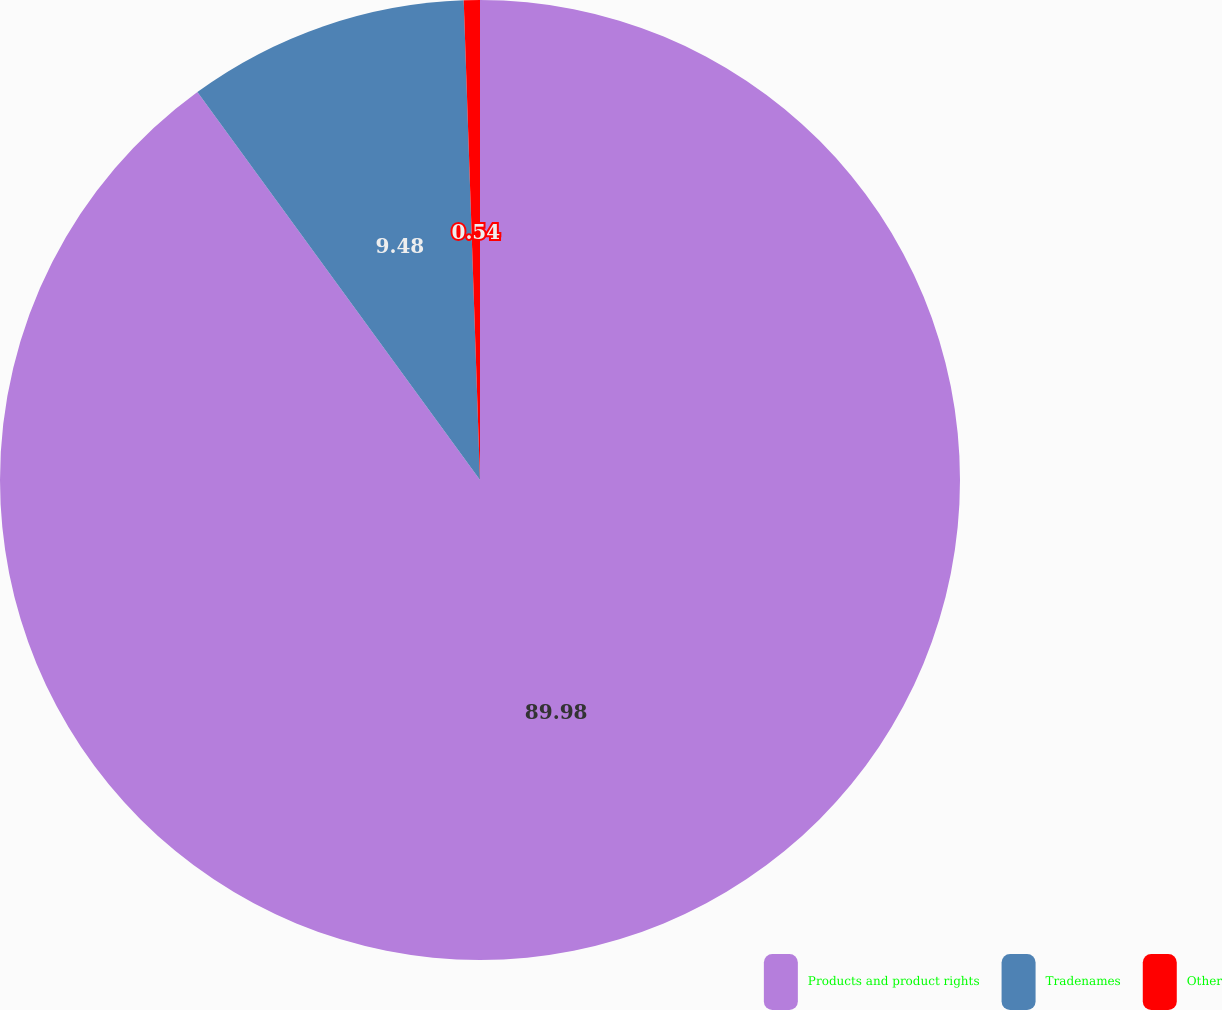Convert chart to OTSL. <chart><loc_0><loc_0><loc_500><loc_500><pie_chart><fcel>Products and product rights<fcel>Tradenames<fcel>Other<nl><fcel>89.98%<fcel>9.48%<fcel>0.54%<nl></chart> 